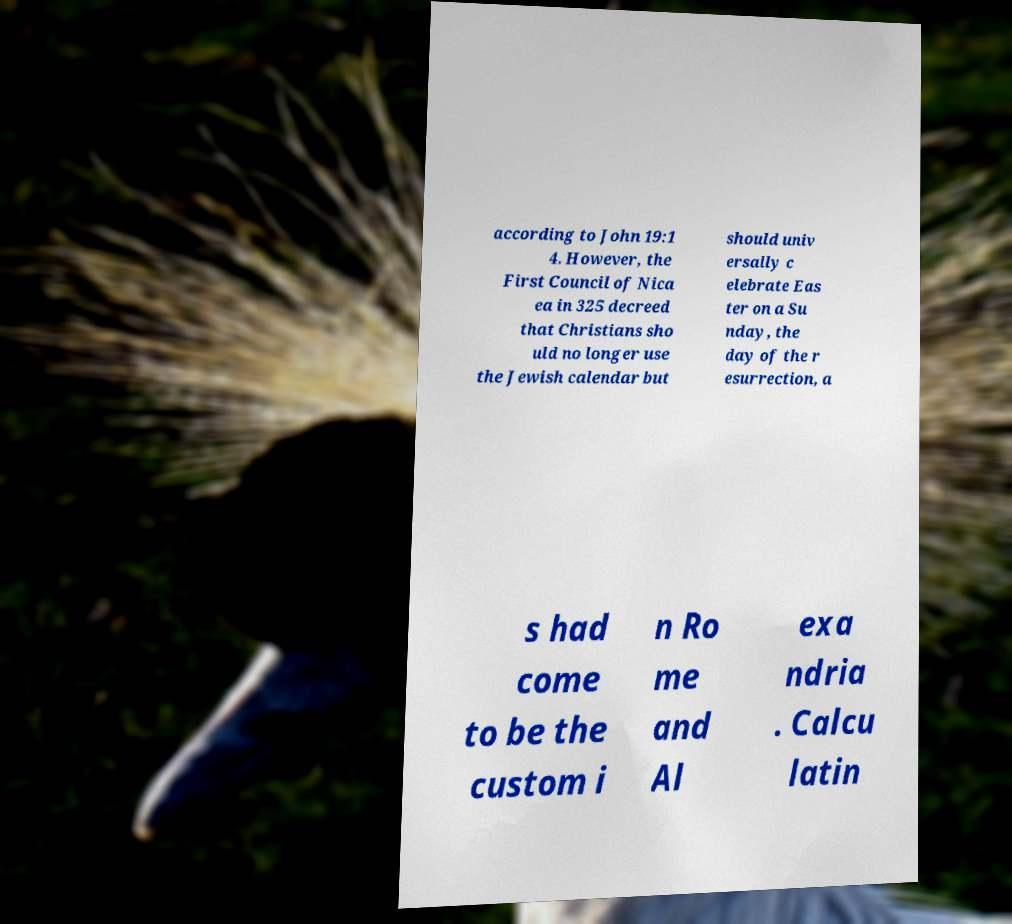For documentation purposes, I need the text within this image transcribed. Could you provide that? according to John 19:1 4. However, the First Council of Nica ea in 325 decreed that Christians sho uld no longer use the Jewish calendar but should univ ersally c elebrate Eas ter on a Su nday, the day of the r esurrection, a s had come to be the custom i n Ro me and Al exa ndria . Calcu latin 